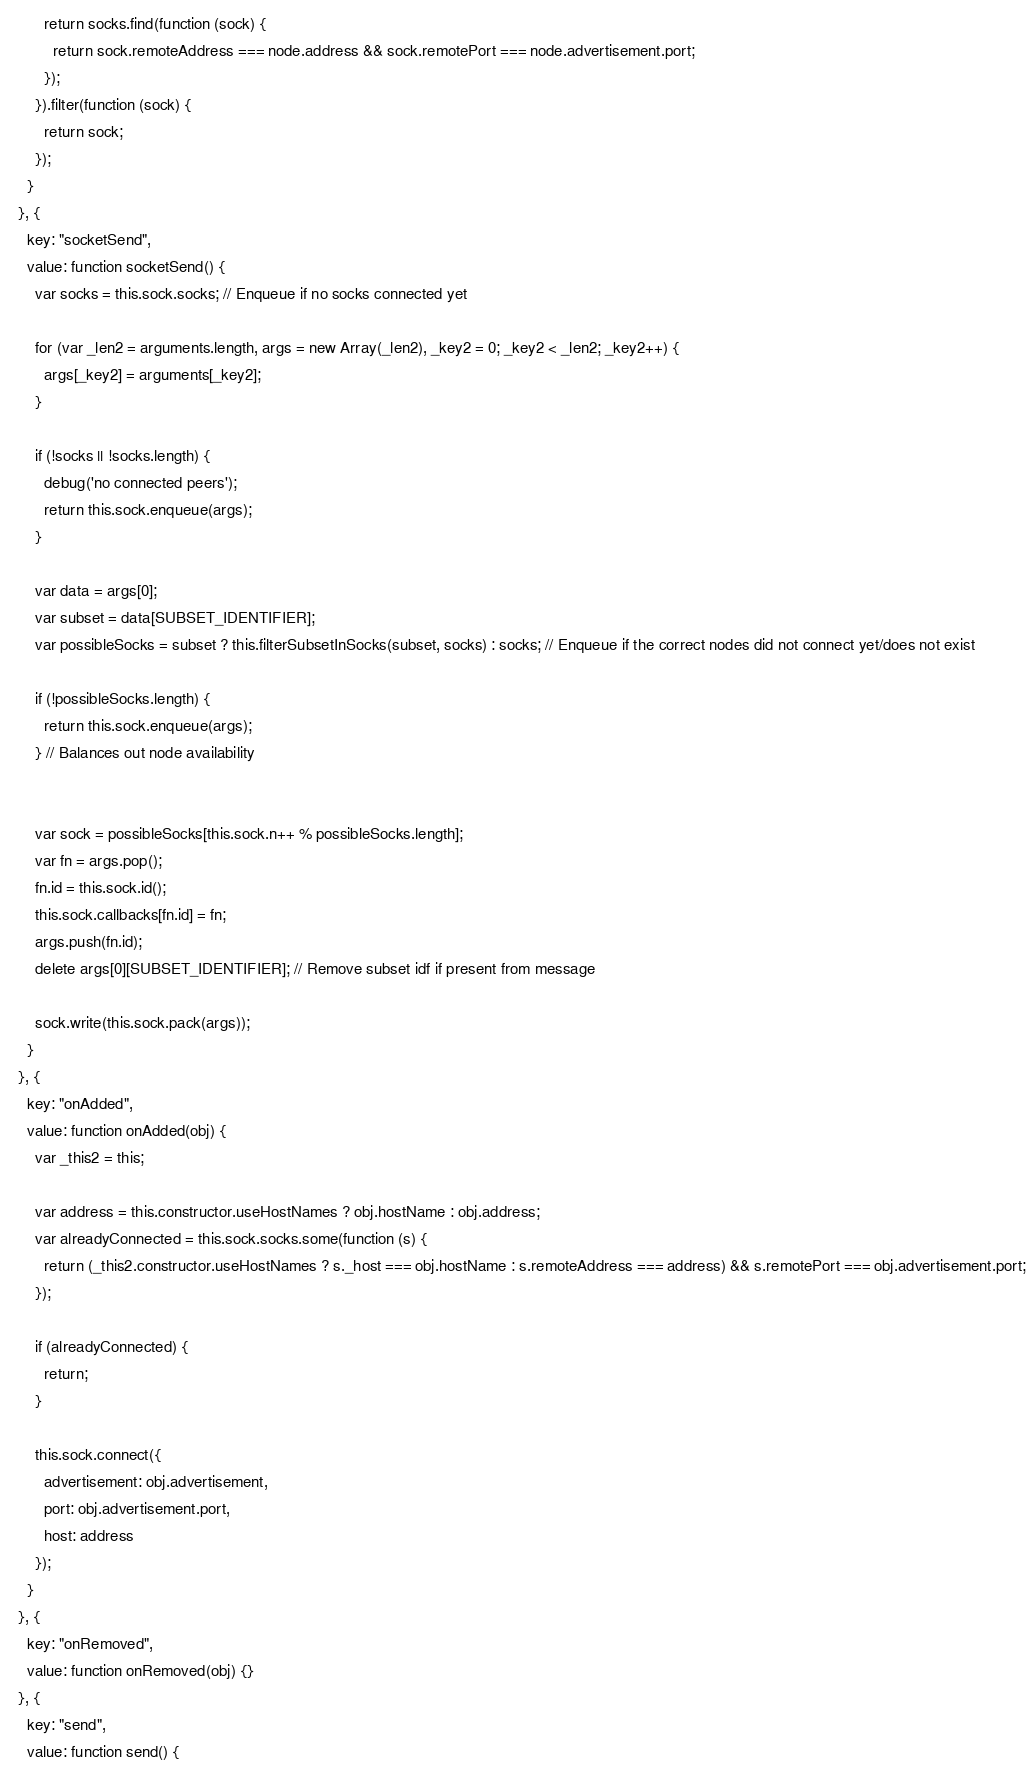<code> <loc_0><loc_0><loc_500><loc_500><_JavaScript_>        return socks.find(function (sock) {
          return sock.remoteAddress === node.address && sock.remotePort === node.advertisement.port;
        });
      }).filter(function (sock) {
        return sock;
      });
    }
  }, {
    key: "socketSend",
    value: function socketSend() {
      var socks = this.sock.socks; // Enqueue if no socks connected yet

      for (var _len2 = arguments.length, args = new Array(_len2), _key2 = 0; _key2 < _len2; _key2++) {
        args[_key2] = arguments[_key2];
      }

      if (!socks || !socks.length) {
        debug('no connected peers');
        return this.sock.enqueue(args);
      }

      var data = args[0];
      var subset = data[SUBSET_IDENTIFIER];
      var possibleSocks = subset ? this.filterSubsetInSocks(subset, socks) : socks; // Enqueue if the correct nodes did not connect yet/does not exist

      if (!possibleSocks.length) {
        return this.sock.enqueue(args);
      } // Balances out node availability


      var sock = possibleSocks[this.sock.n++ % possibleSocks.length];
      var fn = args.pop();
      fn.id = this.sock.id();
      this.sock.callbacks[fn.id] = fn;
      args.push(fn.id);
      delete args[0][SUBSET_IDENTIFIER]; // Remove subset idf if present from message

      sock.write(this.sock.pack(args));
    }
  }, {
    key: "onAdded",
    value: function onAdded(obj) {
      var _this2 = this;

      var address = this.constructor.useHostNames ? obj.hostName : obj.address;
      var alreadyConnected = this.sock.socks.some(function (s) {
        return (_this2.constructor.useHostNames ? s._host === obj.hostName : s.remoteAddress === address) && s.remotePort === obj.advertisement.port;
      });

      if (alreadyConnected) {
        return;
      }

      this.sock.connect({
        advertisement: obj.advertisement,
        port: obj.advertisement.port,
        host: address
      });
    }
  }, {
    key: "onRemoved",
    value: function onRemoved(obj) {}
  }, {
    key: "send",
    value: function send() {</code> 